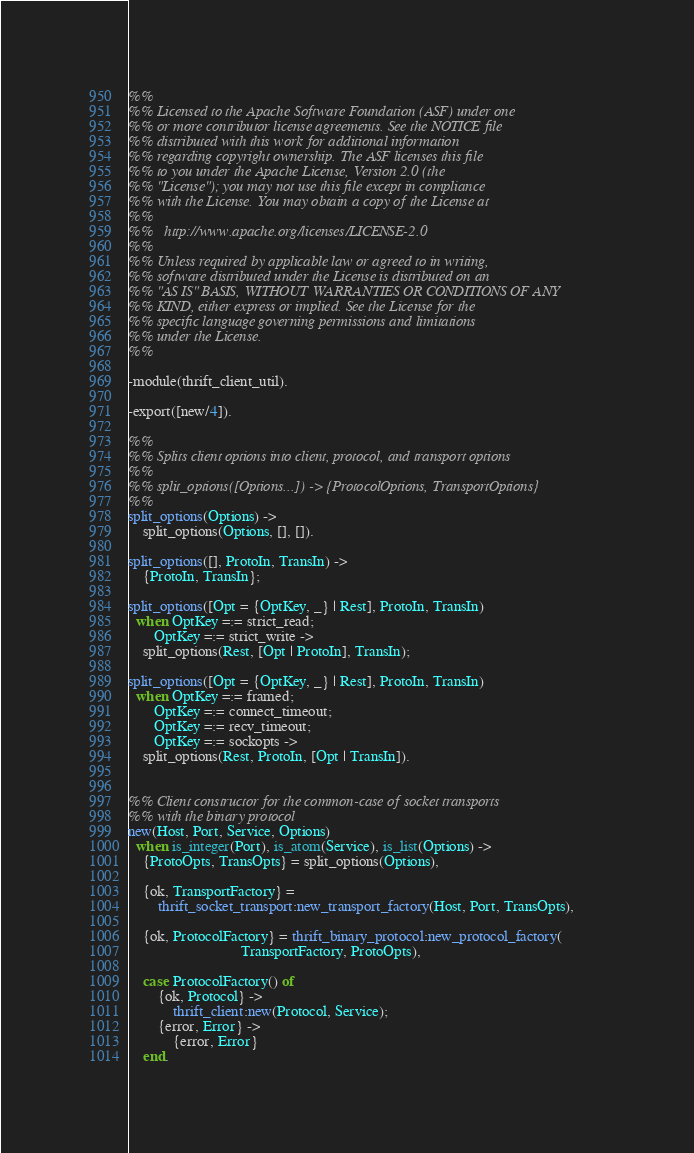<code> <loc_0><loc_0><loc_500><loc_500><_Erlang_>%%
%% Licensed to the Apache Software Foundation (ASF) under one
%% or more contributor license agreements. See the NOTICE file
%% distributed with this work for additional information
%% regarding copyright ownership. The ASF licenses this file
%% to you under the Apache License, Version 2.0 (the
%% "License"); you may not use this file except in compliance
%% with the License. You may obtain a copy of the License at
%%
%%   http://www.apache.org/licenses/LICENSE-2.0
%%
%% Unless required by applicable law or agreed to in writing,
%% software distributed under the License is distributed on an
%% "AS IS" BASIS, WITHOUT WARRANTIES OR CONDITIONS OF ANY
%% KIND, either express or implied. See the License for the
%% specific language governing permissions and limitations
%% under the License.
%%

-module(thrift_client_util).

-export([new/4]).

%%
%% Splits client options into client, protocol, and transport options
%%
%% split_options([Options...]) -> {ProtocolOptions, TransportOptions}
%%
split_options(Options) ->
    split_options(Options, [], []).

split_options([], ProtoIn, TransIn) ->
    {ProtoIn, TransIn};

split_options([Opt = {OptKey, _} | Rest], ProtoIn, TransIn)
  when OptKey =:= strict_read;
       OptKey =:= strict_write ->
    split_options(Rest, [Opt | ProtoIn], TransIn);

split_options([Opt = {OptKey, _} | Rest], ProtoIn, TransIn)
  when OptKey =:= framed;
       OptKey =:= connect_timeout;
       OptKey =:= recv_timeout;
       OptKey =:= sockopts ->
    split_options(Rest, ProtoIn, [Opt | TransIn]).


%% Client constructor for the common-case of socket transports
%% with the binary protocol
new(Host, Port, Service, Options)
  when is_integer(Port), is_atom(Service), is_list(Options) ->
    {ProtoOpts, TransOpts} = split_options(Options),

    {ok, TransportFactory} =
        thrift_socket_transport:new_transport_factory(Host, Port, TransOpts),

    {ok, ProtocolFactory} = thrift_binary_protocol:new_protocol_factory(
                              TransportFactory, ProtoOpts),

    case ProtocolFactory() of
        {ok, Protocol} ->
            thrift_client:new(Protocol, Service);
        {error, Error} ->
            {error, Error}
    end.
</code> 